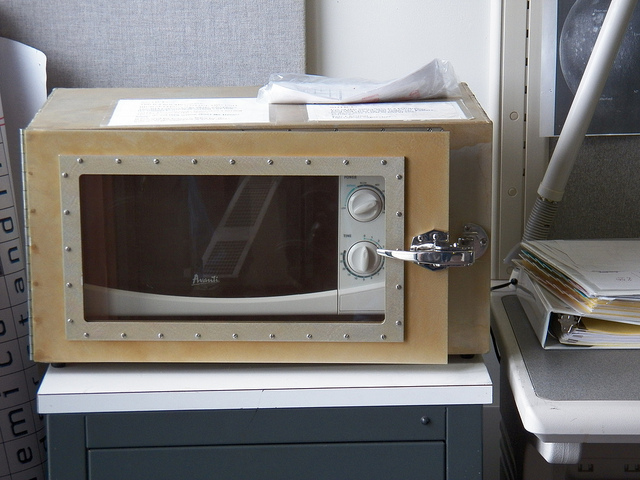Identify the text displayed in this image. e U C Am H I E e 